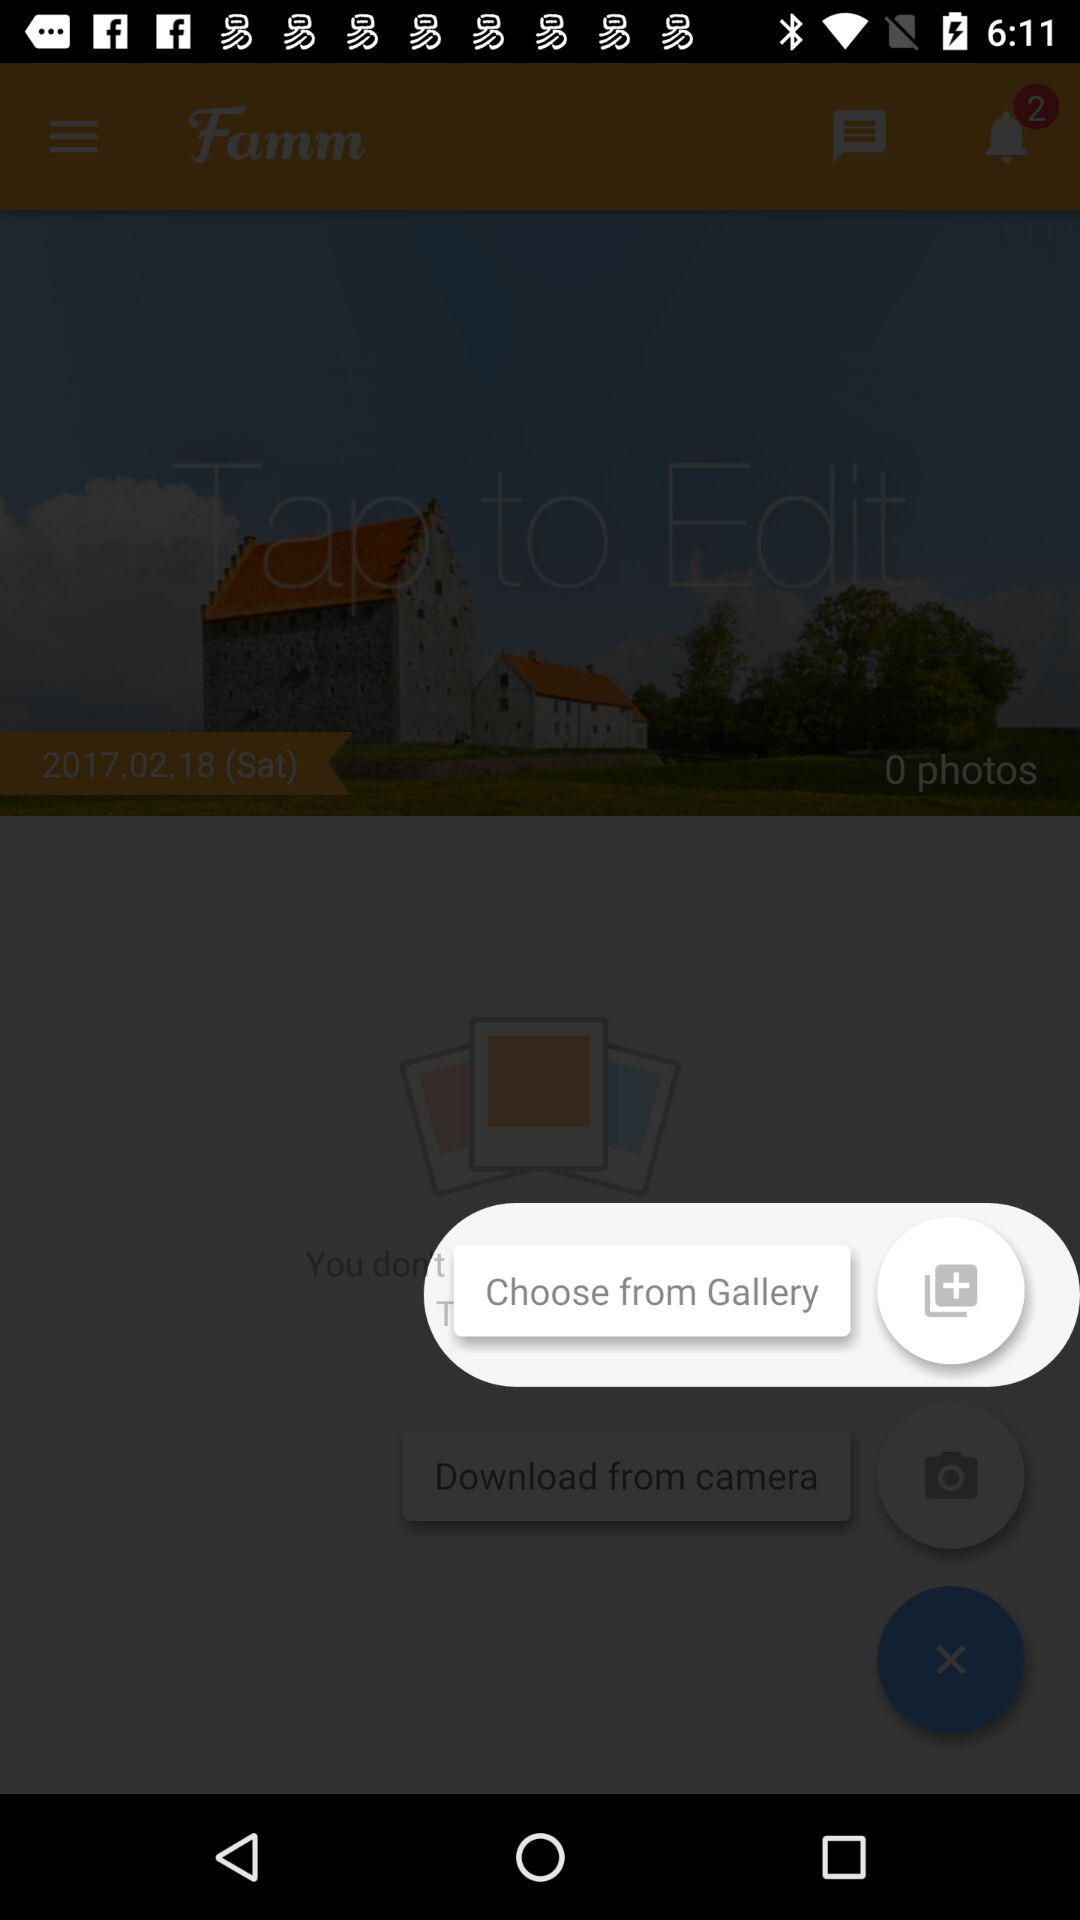How many photos are there?
Answer the question using a single word or phrase. 0 